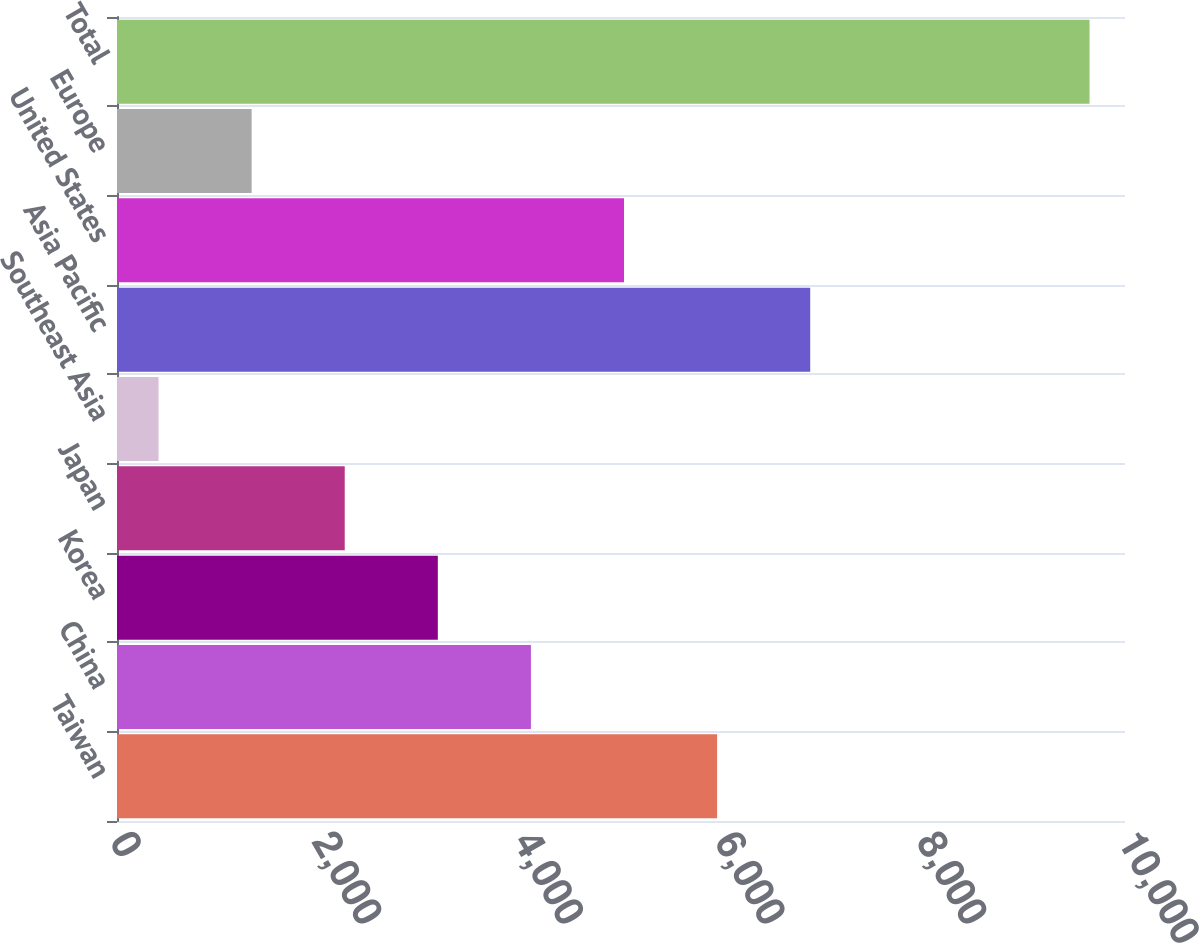Convert chart to OTSL. <chart><loc_0><loc_0><loc_500><loc_500><bar_chart><fcel>Taiwan<fcel>China<fcel>Korea<fcel>Japan<fcel>Southeast Asia<fcel>Asia Pacific<fcel>United States<fcel>Europe<fcel>Total<nl><fcel>5953.6<fcel>4106.4<fcel>3182.8<fcel>2259.2<fcel>412<fcel>6877.2<fcel>5030<fcel>1335.6<fcel>9648<nl></chart> 